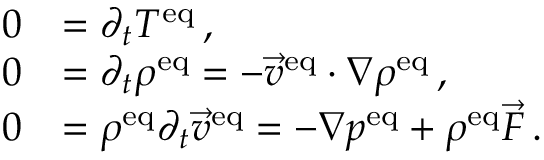Convert formula to latex. <formula><loc_0><loc_0><loc_500><loc_500>\begin{array} { r l } { 0 } & { = \partial _ { t } T ^ { e q } \, , } \\ { 0 } & { = \partial _ { t } \rho ^ { e q } = - \vec { v } ^ { e q } \cdot \nabla \rho ^ { e q } \, , } \\ { 0 } & { = \rho ^ { e q } \partial _ { t } \vec { v } ^ { e q } = - \nabla p ^ { e q } + \rho ^ { e q } \vec { F } \, . } \end{array}</formula> 